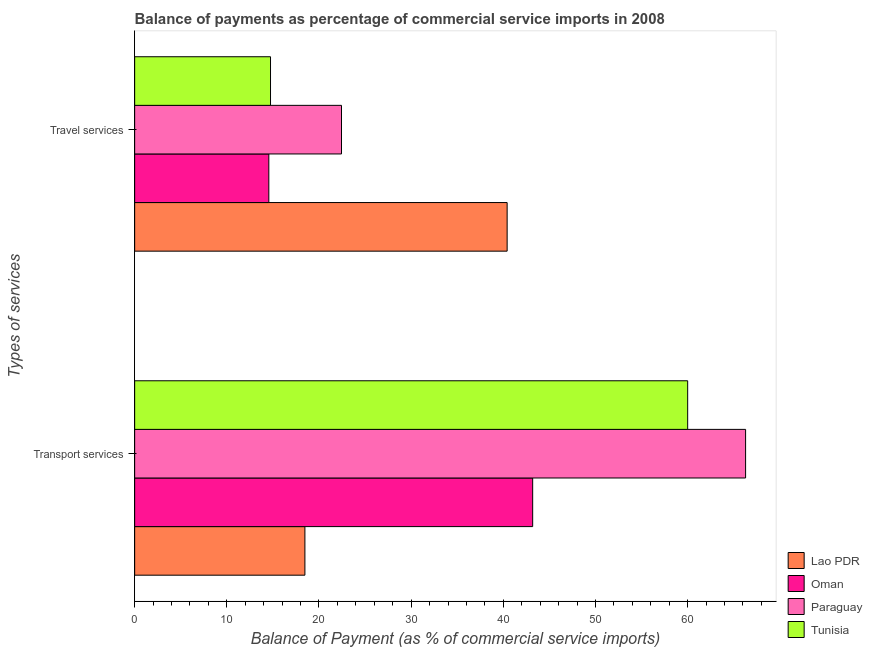How many groups of bars are there?
Ensure brevity in your answer.  2. Are the number of bars per tick equal to the number of legend labels?
Provide a succinct answer. Yes. What is the label of the 1st group of bars from the top?
Your response must be concise. Travel services. What is the balance of payments of travel services in Paraguay?
Offer a very short reply. 22.44. Across all countries, what is the maximum balance of payments of travel services?
Offer a terse response. 40.41. Across all countries, what is the minimum balance of payments of transport services?
Make the answer very short. 18.47. In which country was the balance of payments of travel services maximum?
Offer a very short reply. Lao PDR. In which country was the balance of payments of transport services minimum?
Provide a succinct answer. Lao PDR. What is the total balance of payments of transport services in the graph?
Provide a short and direct response. 187.95. What is the difference between the balance of payments of transport services in Oman and that in Tunisia?
Keep it short and to the point. -16.82. What is the difference between the balance of payments of travel services in Paraguay and the balance of payments of transport services in Oman?
Keep it short and to the point. -20.74. What is the average balance of payments of travel services per country?
Offer a very short reply. 23.04. What is the difference between the balance of payments of transport services and balance of payments of travel services in Tunisia?
Your answer should be compact. 45.26. What is the ratio of the balance of payments of transport services in Oman to that in Paraguay?
Offer a terse response. 0.65. In how many countries, is the balance of payments of travel services greater than the average balance of payments of travel services taken over all countries?
Offer a very short reply. 1. What does the 2nd bar from the top in Travel services represents?
Make the answer very short. Paraguay. What does the 2nd bar from the bottom in Transport services represents?
Keep it short and to the point. Oman. How many bars are there?
Your response must be concise. 8. What is the difference between two consecutive major ticks on the X-axis?
Your answer should be very brief. 10. Are the values on the major ticks of X-axis written in scientific E-notation?
Give a very brief answer. No. Does the graph contain grids?
Offer a very short reply. No. How many legend labels are there?
Provide a short and direct response. 4. How are the legend labels stacked?
Give a very brief answer. Vertical. What is the title of the graph?
Give a very brief answer. Balance of payments as percentage of commercial service imports in 2008. What is the label or title of the X-axis?
Your answer should be compact. Balance of Payment (as % of commercial service imports). What is the label or title of the Y-axis?
Ensure brevity in your answer.  Types of services. What is the Balance of Payment (as % of commercial service imports) in Lao PDR in Transport services?
Your answer should be compact. 18.47. What is the Balance of Payment (as % of commercial service imports) of Oman in Transport services?
Make the answer very short. 43.19. What is the Balance of Payment (as % of commercial service imports) of Paraguay in Transport services?
Offer a terse response. 66.29. What is the Balance of Payment (as % of commercial service imports) of Tunisia in Transport services?
Ensure brevity in your answer.  60. What is the Balance of Payment (as % of commercial service imports) in Lao PDR in Travel services?
Keep it short and to the point. 40.41. What is the Balance of Payment (as % of commercial service imports) of Oman in Travel services?
Your answer should be compact. 14.56. What is the Balance of Payment (as % of commercial service imports) in Paraguay in Travel services?
Give a very brief answer. 22.44. What is the Balance of Payment (as % of commercial service imports) in Tunisia in Travel services?
Ensure brevity in your answer.  14.74. Across all Types of services, what is the maximum Balance of Payment (as % of commercial service imports) in Lao PDR?
Make the answer very short. 40.41. Across all Types of services, what is the maximum Balance of Payment (as % of commercial service imports) of Oman?
Keep it short and to the point. 43.19. Across all Types of services, what is the maximum Balance of Payment (as % of commercial service imports) of Paraguay?
Give a very brief answer. 66.29. Across all Types of services, what is the maximum Balance of Payment (as % of commercial service imports) in Tunisia?
Keep it short and to the point. 60. Across all Types of services, what is the minimum Balance of Payment (as % of commercial service imports) of Lao PDR?
Make the answer very short. 18.47. Across all Types of services, what is the minimum Balance of Payment (as % of commercial service imports) of Oman?
Your answer should be compact. 14.56. Across all Types of services, what is the minimum Balance of Payment (as % of commercial service imports) of Paraguay?
Give a very brief answer. 22.44. Across all Types of services, what is the minimum Balance of Payment (as % of commercial service imports) in Tunisia?
Your response must be concise. 14.74. What is the total Balance of Payment (as % of commercial service imports) in Lao PDR in the graph?
Make the answer very short. 58.89. What is the total Balance of Payment (as % of commercial service imports) in Oman in the graph?
Ensure brevity in your answer.  57.74. What is the total Balance of Payment (as % of commercial service imports) of Paraguay in the graph?
Your answer should be very brief. 88.73. What is the total Balance of Payment (as % of commercial service imports) of Tunisia in the graph?
Offer a very short reply. 74.74. What is the difference between the Balance of Payment (as % of commercial service imports) in Lao PDR in Transport services and that in Travel services?
Your answer should be very brief. -21.94. What is the difference between the Balance of Payment (as % of commercial service imports) in Oman in Transport services and that in Travel services?
Keep it short and to the point. 28.63. What is the difference between the Balance of Payment (as % of commercial service imports) in Paraguay in Transport services and that in Travel services?
Provide a short and direct response. 43.84. What is the difference between the Balance of Payment (as % of commercial service imports) of Tunisia in Transport services and that in Travel services?
Keep it short and to the point. 45.26. What is the difference between the Balance of Payment (as % of commercial service imports) of Lao PDR in Transport services and the Balance of Payment (as % of commercial service imports) of Oman in Travel services?
Your answer should be compact. 3.91. What is the difference between the Balance of Payment (as % of commercial service imports) of Lao PDR in Transport services and the Balance of Payment (as % of commercial service imports) of Paraguay in Travel services?
Offer a terse response. -3.97. What is the difference between the Balance of Payment (as % of commercial service imports) of Lao PDR in Transport services and the Balance of Payment (as % of commercial service imports) of Tunisia in Travel services?
Offer a very short reply. 3.73. What is the difference between the Balance of Payment (as % of commercial service imports) in Oman in Transport services and the Balance of Payment (as % of commercial service imports) in Paraguay in Travel services?
Ensure brevity in your answer.  20.74. What is the difference between the Balance of Payment (as % of commercial service imports) in Oman in Transport services and the Balance of Payment (as % of commercial service imports) in Tunisia in Travel services?
Make the answer very short. 28.44. What is the difference between the Balance of Payment (as % of commercial service imports) in Paraguay in Transport services and the Balance of Payment (as % of commercial service imports) in Tunisia in Travel services?
Provide a short and direct response. 51.55. What is the average Balance of Payment (as % of commercial service imports) in Lao PDR per Types of services?
Ensure brevity in your answer.  29.44. What is the average Balance of Payment (as % of commercial service imports) in Oman per Types of services?
Your answer should be compact. 28.87. What is the average Balance of Payment (as % of commercial service imports) of Paraguay per Types of services?
Your response must be concise. 44.37. What is the average Balance of Payment (as % of commercial service imports) in Tunisia per Types of services?
Make the answer very short. 37.37. What is the difference between the Balance of Payment (as % of commercial service imports) of Lao PDR and Balance of Payment (as % of commercial service imports) of Oman in Transport services?
Give a very brief answer. -24.71. What is the difference between the Balance of Payment (as % of commercial service imports) in Lao PDR and Balance of Payment (as % of commercial service imports) in Paraguay in Transport services?
Provide a succinct answer. -47.82. What is the difference between the Balance of Payment (as % of commercial service imports) in Lao PDR and Balance of Payment (as % of commercial service imports) in Tunisia in Transport services?
Ensure brevity in your answer.  -41.53. What is the difference between the Balance of Payment (as % of commercial service imports) of Oman and Balance of Payment (as % of commercial service imports) of Paraguay in Transport services?
Your answer should be very brief. -23.1. What is the difference between the Balance of Payment (as % of commercial service imports) of Oman and Balance of Payment (as % of commercial service imports) of Tunisia in Transport services?
Ensure brevity in your answer.  -16.82. What is the difference between the Balance of Payment (as % of commercial service imports) of Paraguay and Balance of Payment (as % of commercial service imports) of Tunisia in Transport services?
Provide a short and direct response. 6.29. What is the difference between the Balance of Payment (as % of commercial service imports) in Lao PDR and Balance of Payment (as % of commercial service imports) in Oman in Travel services?
Your answer should be compact. 25.86. What is the difference between the Balance of Payment (as % of commercial service imports) in Lao PDR and Balance of Payment (as % of commercial service imports) in Paraguay in Travel services?
Make the answer very short. 17.97. What is the difference between the Balance of Payment (as % of commercial service imports) of Lao PDR and Balance of Payment (as % of commercial service imports) of Tunisia in Travel services?
Provide a short and direct response. 25.67. What is the difference between the Balance of Payment (as % of commercial service imports) of Oman and Balance of Payment (as % of commercial service imports) of Paraguay in Travel services?
Your answer should be compact. -7.89. What is the difference between the Balance of Payment (as % of commercial service imports) in Oman and Balance of Payment (as % of commercial service imports) in Tunisia in Travel services?
Give a very brief answer. -0.18. What is the difference between the Balance of Payment (as % of commercial service imports) of Paraguay and Balance of Payment (as % of commercial service imports) of Tunisia in Travel services?
Make the answer very short. 7.7. What is the ratio of the Balance of Payment (as % of commercial service imports) in Lao PDR in Transport services to that in Travel services?
Your response must be concise. 0.46. What is the ratio of the Balance of Payment (as % of commercial service imports) in Oman in Transport services to that in Travel services?
Your answer should be compact. 2.97. What is the ratio of the Balance of Payment (as % of commercial service imports) of Paraguay in Transport services to that in Travel services?
Provide a succinct answer. 2.95. What is the ratio of the Balance of Payment (as % of commercial service imports) in Tunisia in Transport services to that in Travel services?
Provide a short and direct response. 4.07. What is the difference between the highest and the second highest Balance of Payment (as % of commercial service imports) in Lao PDR?
Your answer should be very brief. 21.94. What is the difference between the highest and the second highest Balance of Payment (as % of commercial service imports) of Oman?
Offer a terse response. 28.63. What is the difference between the highest and the second highest Balance of Payment (as % of commercial service imports) in Paraguay?
Keep it short and to the point. 43.84. What is the difference between the highest and the second highest Balance of Payment (as % of commercial service imports) in Tunisia?
Keep it short and to the point. 45.26. What is the difference between the highest and the lowest Balance of Payment (as % of commercial service imports) in Lao PDR?
Provide a succinct answer. 21.94. What is the difference between the highest and the lowest Balance of Payment (as % of commercial service imports) of Oman?
Your answer should be very brief. 28.63. What is the difference between the highest and the lowest Balance of Payment (as % of commercial service imports) in Paraguay?
Keep it short and to the point. 43.84. What is the difference between the highest and the lowest Balance of Payment (as % of commercial service imports) of Tunisia?
Offer a terse response. 45.26. 